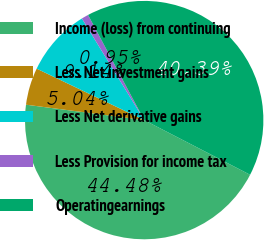Convert chart to OTSL. <chart><loc_0><loc_0><loc_500><loc_500><pie_chart><fcel>Income (loss) from continuing<fcel>Less Net investment gains<fcel>Less Net derivative gains<fcel>Less Provision for income tax<fcel>Operatingearnings<nl><fcel>44.48%<fcel>5.04%<fcel>9.14%<fcel>0.95%<fcel>40.39%<nl></chart> 